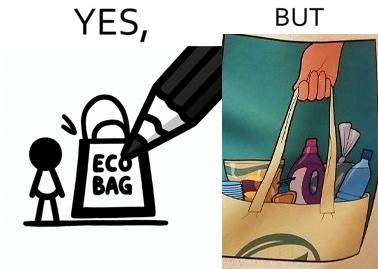Does this image contain satire or humor? Yes, this image is satirical. 